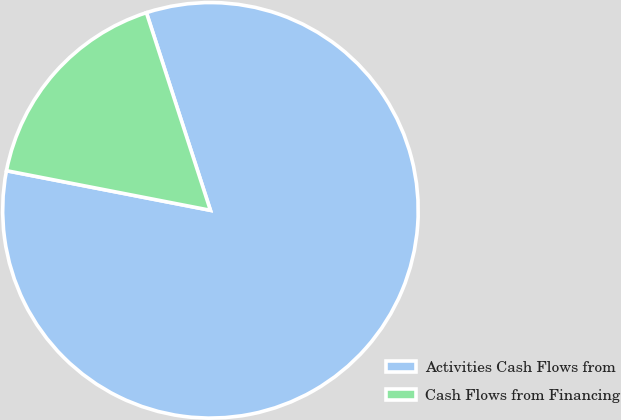<chart> <loc_0><loc_0><loc_500><loc_500><pie_chart><fcel>Activities Cash Flows from<fcel>Cash Flows from Financing<nl><fcel>83.04%<fcel>16.96%<nl></chart> 